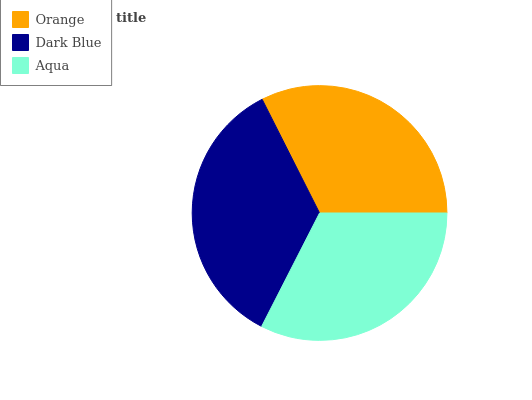Is Orange the minimum?
Answer yes or no. Yes. Is Dark Blue the maximum?
Answer yes or no. Yes. Is Aqua the minimum?
Answer yes or no. No. Is Aqua the maximum?
Answer yes or no. No. Is Dark Blue greater than Aqua?
Answer yes or no. Yes. Is Aqua less than Dark Blue?
Answer yes or no. Yes. Is Aqua greater than Dark Blue?
Answer yes or no. No. Is Dark Blue less than Aqua?
Answer yes or no. No. Is Aqua the high median?
Answer yes or no. Yes. Is Aqua the low median?
Answer yes or no. Yes. Is Orange the high median?
Answer yes or no. No. Is Orange the low median?
Answer yes or no. No. 